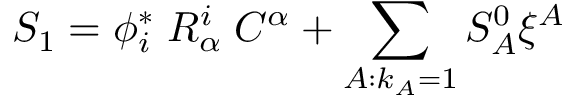Convert formula to latex. <formula><loc_0><loc_0><loc_500><loc_500>S _ { 1 } = \phi _ { i } ^ { * } \, R _ { \alpha } ^ { i } \, C ^ { \alpha } + \sum _ { A \colon k _ { A } = 1 } S _ { A } ^ { 0 } \xi ^ { A }</formula> 